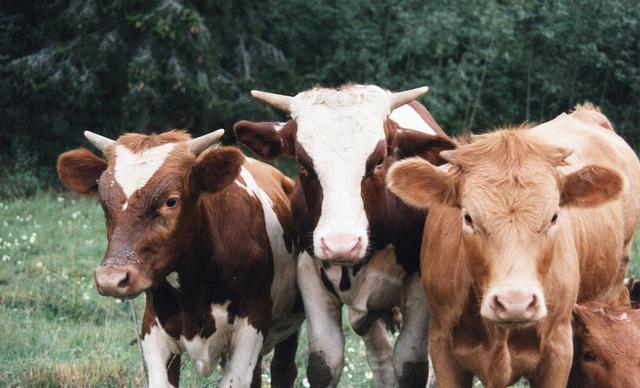Are the cows all the same?
Be succinct. No. How many cows?
Short answer required. 3. What can the cows eat that is shown in this photo?
Answer briefly. Grass. 